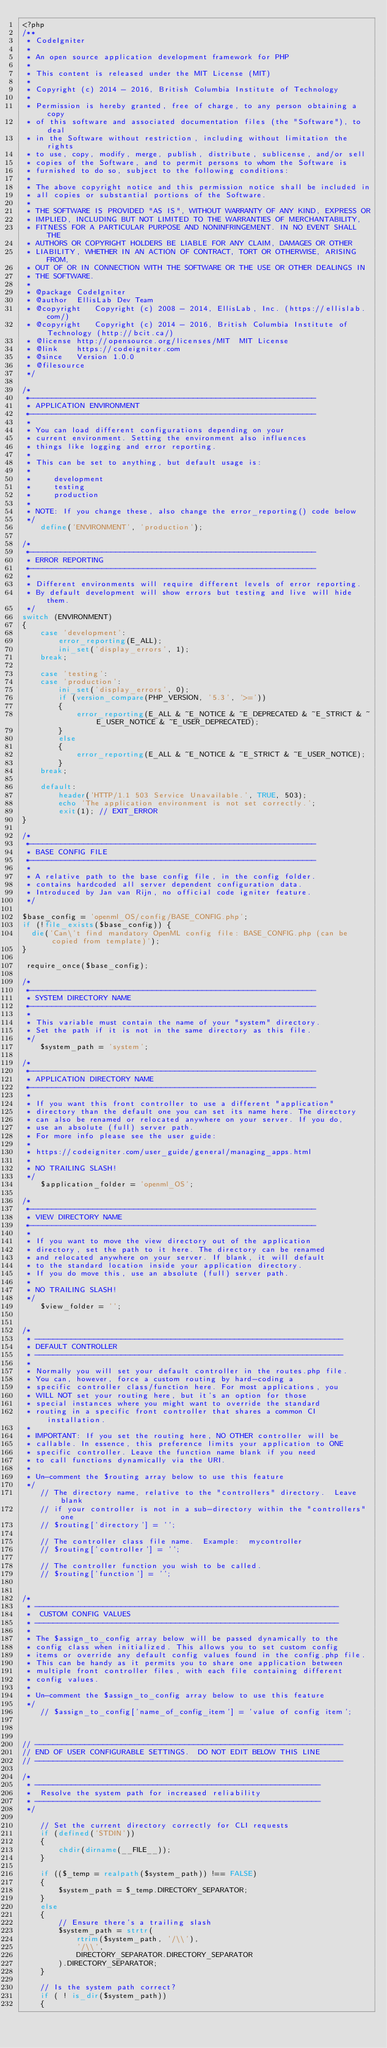Convert code to text. <code><loc_0><loc_0><loc_500><loc_500><_PHP_><?php
/**
 * CodeIgniter
 *
 * An open source application development framework for PHP
 *
 * This content is released under the MIT License (MIT)
 *
 * Copyright (c) 2014 - 2016, British Columbia Institute of Technology
 *
 * Permission is hereby granted, free of charge, to any person obtaining a copy
 * of this software and associated documentation files (the "Software"), to deal
 * in the Software without restriction, including without limitation the rights
 * to use, copy, modify, merge, publish, distribute, sublicense, and/or sell
 * copies of the Software, and to permit persons to whom the Software is
 * furnished to do so, subject to the following conditions:
 *
 * The above copyright notice and this permission notice shall be included in
 * all copies or substantial portions of the Software.
 *
 * THE SOFTWARE IS PROVIDED "AS IS", WITHOUT WARRANTY OF ANY KIND, EXPRESS OR
 * IMPLIED, INCLUDING BUT NOT LIMITED TO THE WARRANTIES OF MERCHANTABILITY,
 * FITNESS FOR A PARTICULAR PURPOSE AND NONINFRINGEMENT. IN NO EVENT SHALL THE
 * AUTHORS OR COPYRIGHT HOLDERS BE LIABLE FOR ANY CLAIM, DAMAGES OR OTHER
 * LIABILITY, WHETHER IN AN ACTION OF CONTRACT, TORT OR OTHERWISE, ARISING FROM,
 * OUT OF OR IN CONNECTION WITH THE SOFTWARE OR THE USE OR OTHER DEALINGS IN
 * THE SOFTWARE.
 *
 * @package	CodeIgniter
 * @author	EllisLab Dev Team
 * @copyright	Copyright (c) 2008 - 2014, EllisLab, Inc. (https://ellislab.com/)
 * @copyright	Copyright (c) 2014 - 2016, British Columbia Institute of Technology (http://bcit.ca/)
 * @license	http://opensource.org/licenses/MIT	MIT License
 * @link	https://codeigniter.com
 * @since	Version 1.0.0
 * @filesource
 */

/*
 *---------------------------------------------------------------
 * APPLICATION ENVIRONMENT
 *---------------------------------------------------------------
 *
 * You can load different configurations depending on your
 * current environment. Setting the environment also influences
 * things like logging and error reporting.
 *
 * This can be set to anything, but default usage is:
 *
 *     development
 *     testing
 *     production
 *
 * NOTE: If you change these, also change the error_reporting() code below
 */
	define('ENVIRONMENT', 'production');

/*
 *---------------------------------------------------------------
 * ERROR REPORTING
 *---------------------------------------------------------------
 *
 * Different environments will require different levels of error reporting.
 * By default development will show errors but testing and live will hide them.
 */
switch (ENVIRONMENT)
{
	case 'development':
		error_reporting(E_ALL);
		ini_set('display_errors', 1);
	break;

	case 'testing':
	case 'production':
		ini_set('display_errors', 0);
		if (version_compare(PHP_VERSION, '5.3', '>='))
		{
			error_reporting(E_ALL & ~E_NOTICE & ~E_DEPRECATED & ~E_STRICT & ~E_USER_NOTICE & ~E_USER_DEPRECATED);
		}
		else
		{
			error_reporting(E_ALL & ~E_NOTICE & ~E_STRICT & ~E_USER_NOTICE);
		}
	break;

	default:
		header('HTTP/1.1 503 Service Unavailable.', TRUE, 503);
		echo 'The application environment is not set correctly.';
		exit(1); // EXIT_ERROR
}

/*
 *---------------------------------------------------------------
 * BASE CONFIG FILE
 *---------------------------------------------------------------
 *
 * A relative path to the base config file, in the config folder.
 * contains hardcoded all server dependent configuration data.
 * Introduced by Jan van Rijn, no official code igniter feature.
 */

$base_config = 'openml_OS/config/BASE_CONFIG.php';
if (!file_exists($base_config)) {
  die('Can\'t find mandatory OpenML config file: BASE_CONFIG.php (can be copied from template)');
}

 require_once($base_config);

/*
 *---------------------------------------------------------------
 * SYSTEM DIRECTORY NAME
 *---------------------------------------------------------------
 *
 * This variable must contain the name of your "system" directory.
 * Set the path if it is not in the same directory as this file.
 */
	$system_path = 'system';

/*
 *---------------------------------------------------------------
 * APPLICATION DIRECTORY NAME
 *---------------------------------------------------------------
 *
 * If you want this front controller to use a different "application"
 * directory than the default one you can set its name here. The directory
 * can also be renamed or relocated anywhere on your server. If you do,
 * use an absolute (full) server path.
 * For more info please see the user guide:
 *
 * https://codeigniter.com/user_guide/general/managing_apps.html
 *
 * NO TRAILING SLASH!
 */
	$application_folder = 'openml_OS';

/*
 *---------------------------------------------------------------
 * VIEW DIRECTORY NAME
 *---------------------------------------------------------------
 *
 * If you want to move the view directory out of the application
 * directory, set the path to it here. The directory can be renamed
 * and relocated anywhere on your server. If blank, it will default
 * to the standard location inside your application directory.
 * If you do move this, use an absolute (full) server path.
 *
 * NO TRAILING SLASH!
 */
	$view_folder = '';


/*
 * --------------------------------------------------------------------
 * DEFAULT CONTROLLER
 * --------------------------------------------------------------------
 *
 * Normally you will set your default controller in the routes.php file.
 * You can, however, force a custom routing by hard-coding a
 * specific controller class/function here. For most applications, you
 * WILL NOT set your routing here, but it's an option for those
 * special instances where you might want to override the standard
 * routing in a specific front controller that shares a common CI installation.
 *
 * IMPORTANT: If you set the routing here, NO OTHER controller will be
 * callable. In essence, this preference limits your application to ONE
 * specific controller. Leave the function name blank if you need
 * to call functions dynamically via the URI.
 *
 * Un-comment the $routing array below to use this feature
 */
	// The directory name, relative to the "controllers" directory.  Leave blank
	// if your controller is not in a sub-directory within the "controllers" one
	// $routing['directory'] = '';

	// The controller class file name.  Example:  mycontroller
	// $routing['controller'] = '';

	// The controller function you wish to be called.
	// $routing['function']	= '';


/*
 * -------------------------------------------------------------------
 *  CUSTOM CONFIG VALUES
 * -------------------------------------------------------------------
 *
 * The $assign_to_config array below will be passed dynamically to the
 * config class when initialized. This allows you to set custom config
 * items or override any default config values found in the config.php file.
 * This can be handy as it permits you to share one application between
 * multiple front controller files, with each file containing different
 * config values.
 *
 * Un-comment the $assign_to_config array below to use this feature
 */
	// $assign_to_config['name_of_config_item'] = 'value of config item';



// --------------------------------------------------------------------
// END OF USER CONFIGURABLE SETTINGS.  DO NOT EDIT BELOW THIS LINE
// --------------------------------------------------------------------

/*
 * ---------------------------------------------------------------
 *  Resolve the system path for increased reliability
 * ---------------------------------------------------------------
 */

	// Set the current directory correctly for CLI requests
	if (defined('STDIN'))
	{
		chdir(dirname(__FILE__));
	}

	if (($_temp = realpath($system_path)) !== FALSE)
	{
		$system_path = $_temp.DIRECTORY_SEPARATOR;
	}
	else
	{
		// Ensure there's a trailing slash
		$system_path = strtr(
			rtrim($system_path, '/\\'),
			'/\\',
			DIRECTORY_SEPARATOR.DIRECTORY_SEPARATOR
		).DIRECTORY_SEPARATOR;
	}

	// Is the system path correct?
	if ( ! is_dir($system_path))
	{</code> 